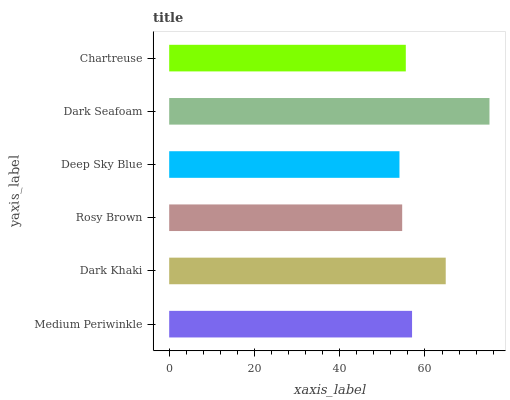Is Deep Sky Blue the minimum?
Answer yes or no. Yes. Is Dark Seafoam the maximum?
Answer yes or no. Yes. Is Dark Khaki the minimum?
Answer yes or no. No. Is Dark Khaki the maximum?
Answer yes or no. No. Is Dark Khaki greater than Medium Periwinkle?
Answer yes or no. Yes. Is Medium Periwinkle less than Dark Khaki?
Answer yes or no. Yes. Is Medium Periwinkle greater than Dark Khaki?
Answer yes or no. No. Is Dark Khaki less than Medium Periwinkle?
Answer yes or no. No. Is Medium Periwinkle the high median?
Answer yes or no. Yes. Is Chartreuse the low median?
Answer yes or no. Yes. Is Rosy Brown the high median?
Answer yes or no. No. Is Rosy Brown the low median?
Answer yes or no. No. 